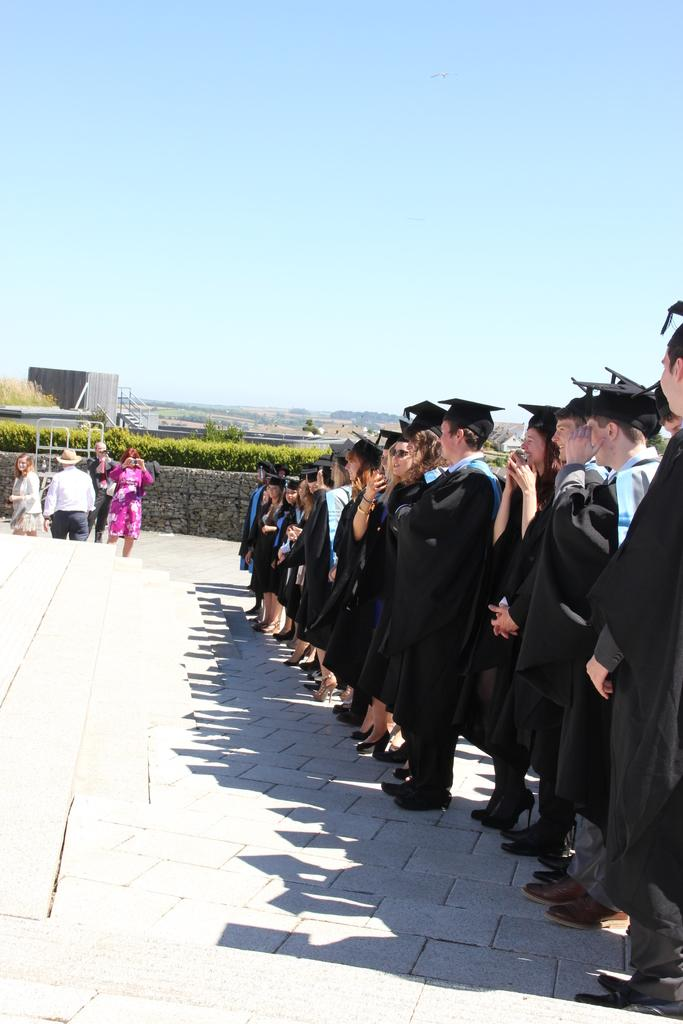What can be seen in the image in terms of human presence? There are groups of people in the image. What other elements are present in the image besides people? There are plants and a building visible in the image. What is visible in the background of the image? The sky is visible in the image. How many jellyfish can be seen swimming in the water in the image? There are no jellyfish or water present in the image. What type of bun is being served to the people in the image? There is no bun visible in the image. 